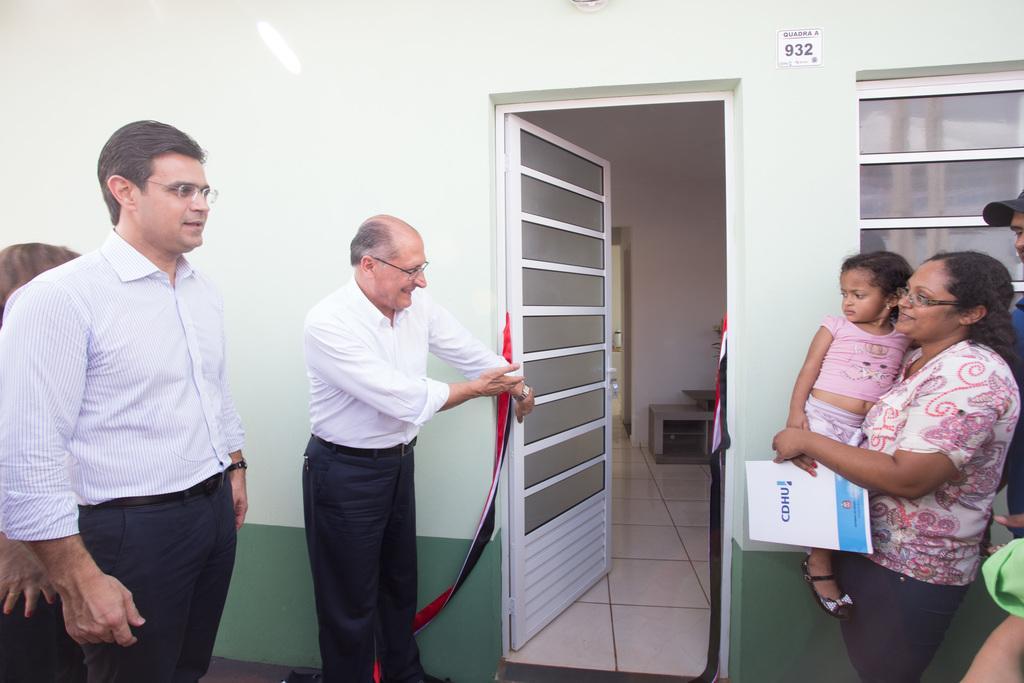Describe this image in one or two sentences. In this image, I can see few people standing and a woman carrying a girl. There is a room with a door and objects in it. On the right side of the image, I can see a window to the wall. 